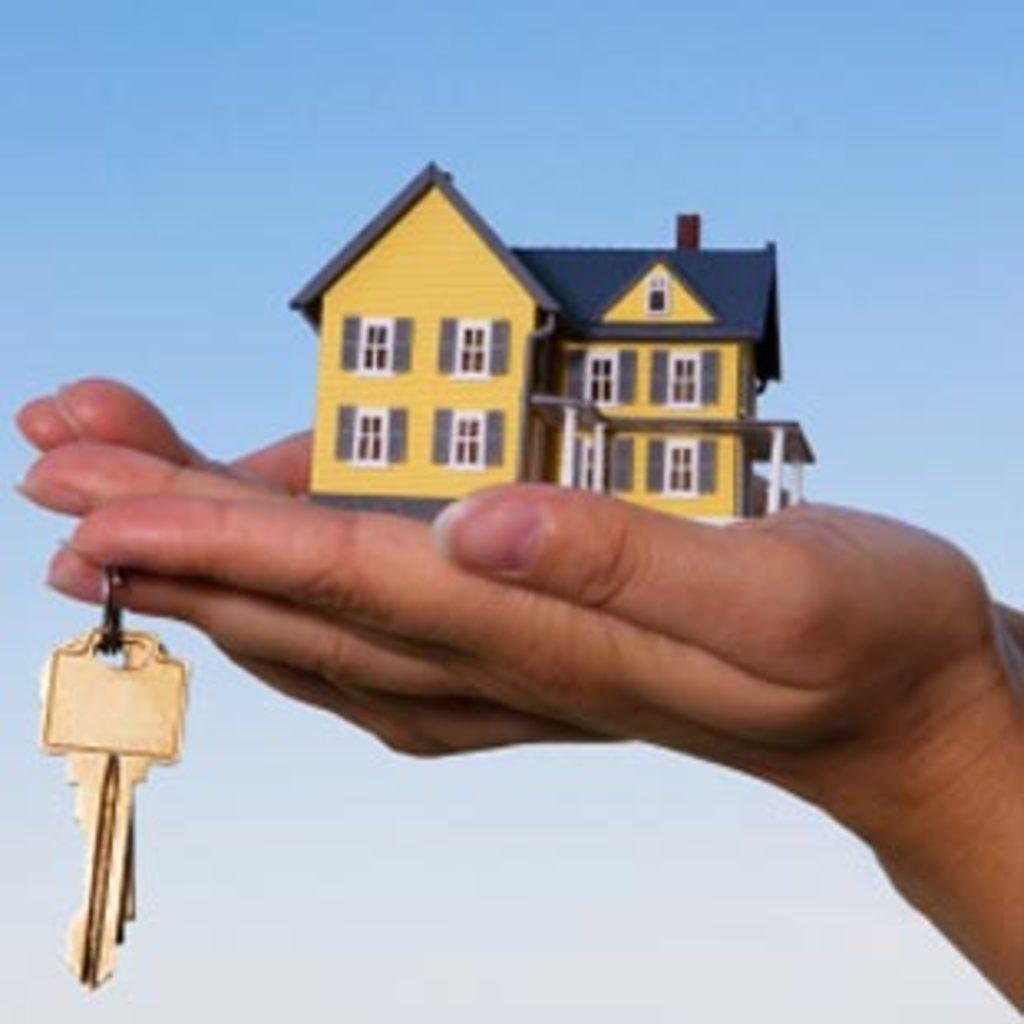What is in the palm of the hand in the image? There is a house toy in the palm of the hand. What else is the hand doing in the image? One of the fingers is holding keys. What type of bead is being used to decorate the field in the image? There is no bead or field present in the image; it features a hand holding a house toy and keys. 